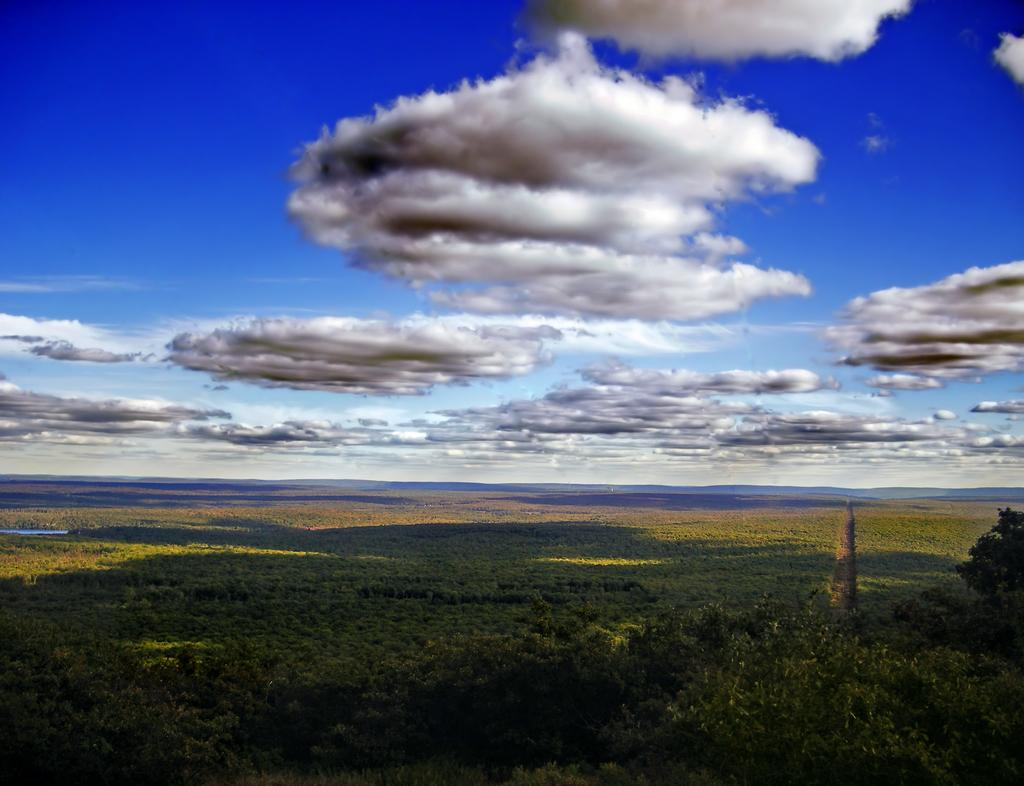What type of natural elements can be seen in the image? There are trees and plants in the image. Where is the water located in the image? The water is visible on the left side of the image. What is visible at the top of the image? The sky is visible at the top of the image. What type of cream can be seen on the car in the image? There is no car or cream present in the image. How much milk is visible in the image? There is no milk present in the image. 